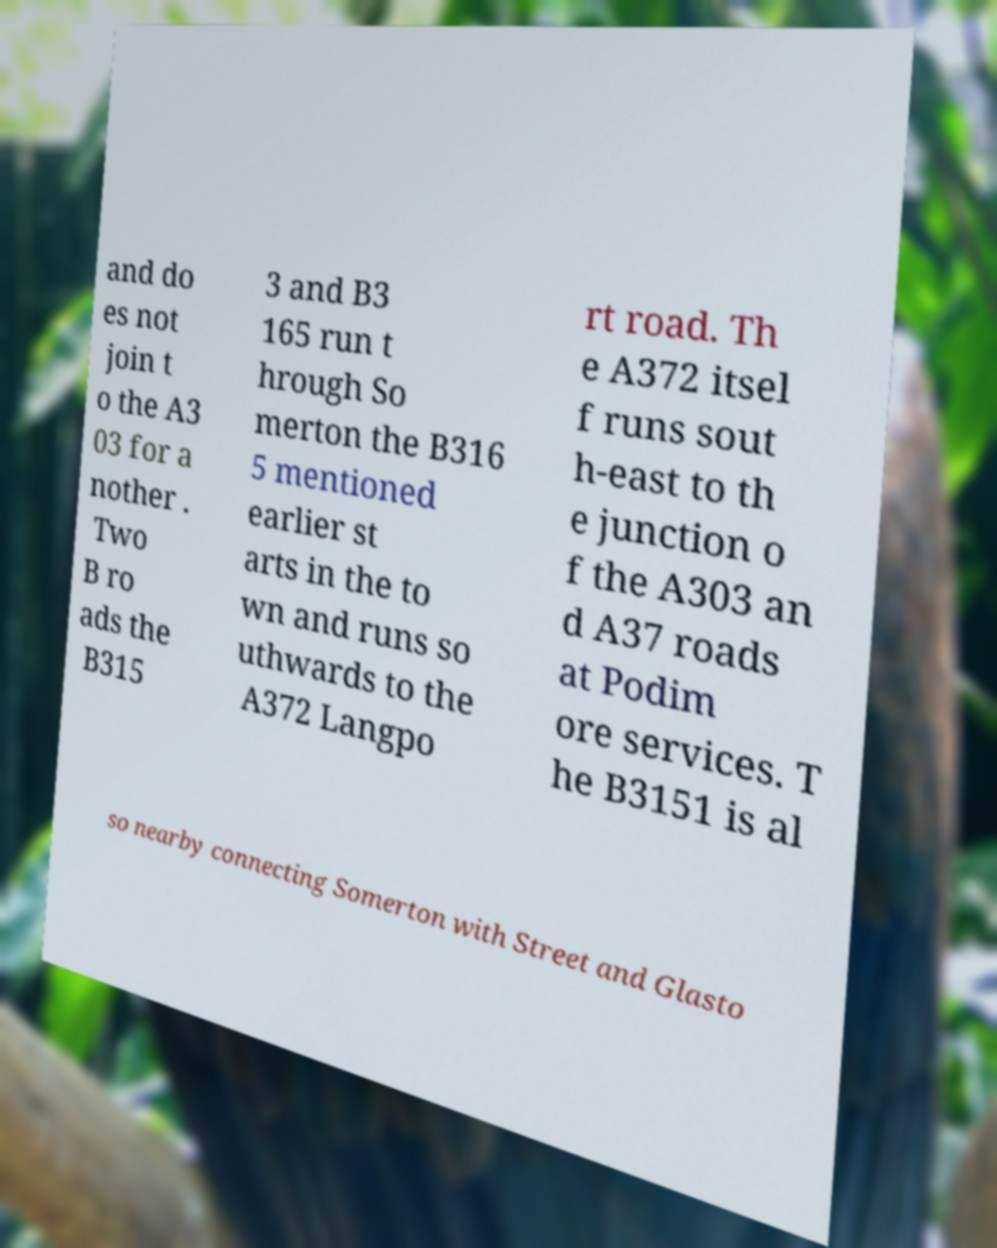Please identify and transcribe the text found in this image. and do es not join t o the A3 03 for a nother . Two B ro ads the B315 3 and B3 165 run t hrough So merton the B316 5 mentioned earlier st arts in the to wn and runs so uthwards to the A372 Langpo rt road. Th e A372 itsel f runs sout h-east to th e junction o f the A303 an d A37 roads at Podim ore services. T he B3151 is al so nearby connecting Somerton with Street and Glasto 